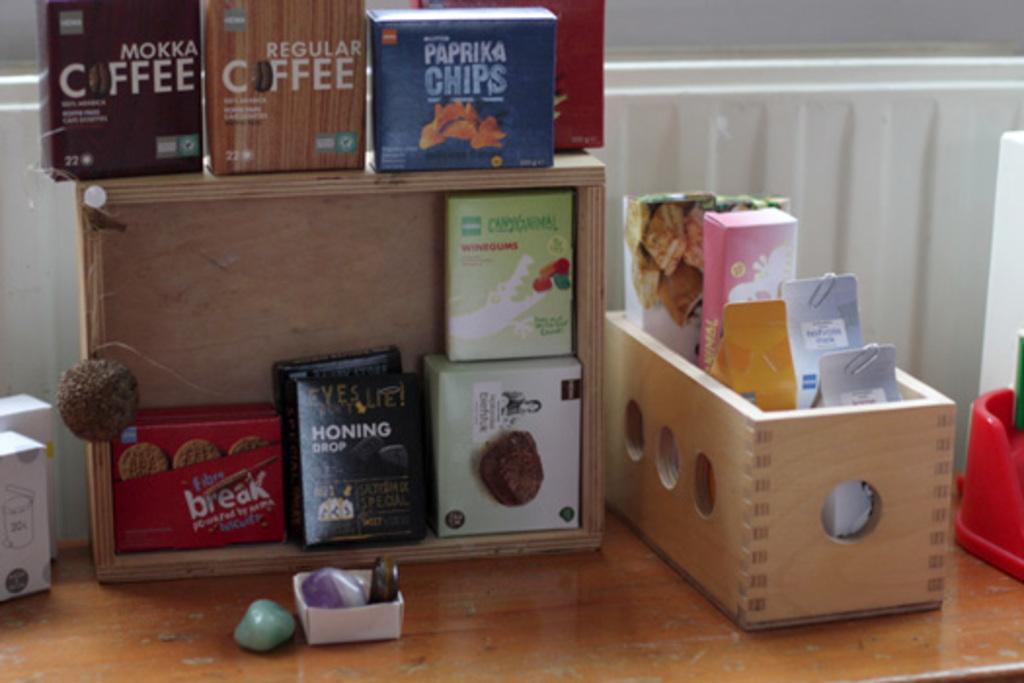How would you summarize this image in a sentence or two? In this picture I can see boxes, there are three items with the paper clips, there are stones and some other objects on the table, and in the background there is a wall. 